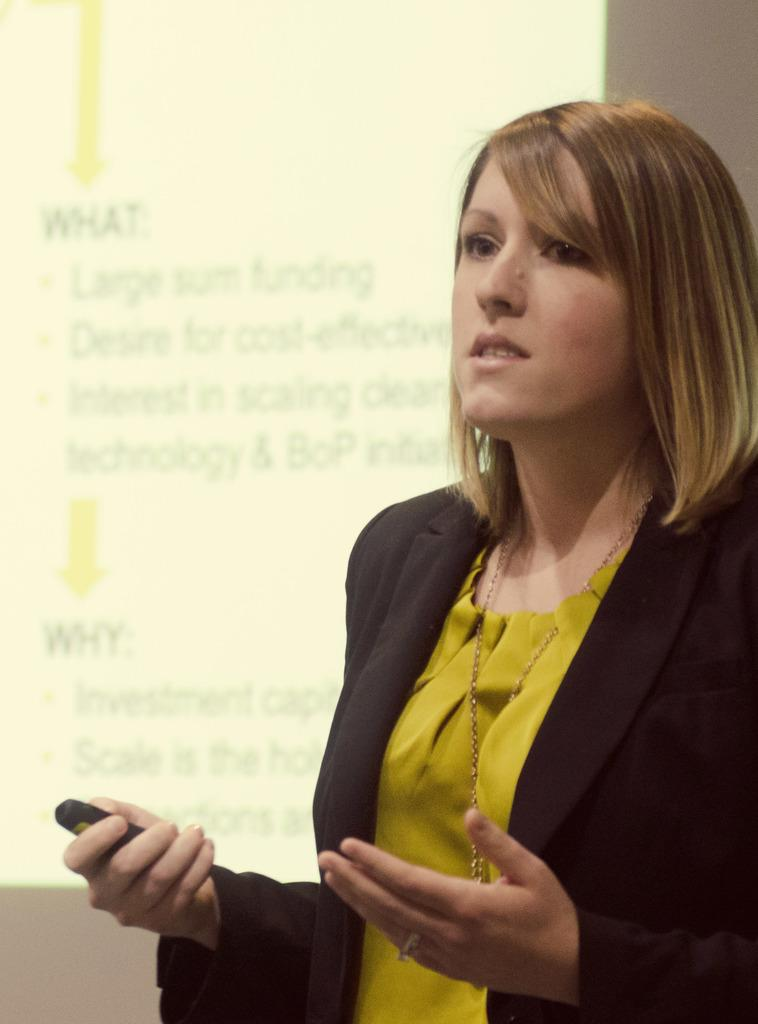Who is the main subject in the image? There is a woman in the image. What is the woman holding in the image? The woman is holding an electronic gadget. What type of clothing is the woman wearing? The woman is wearing a jacket. Can you describe the background of the image? There might be a projector screen in the background of the image, and if present, text is visible on it. What type of haircut does the boy have in the image? There is no boy present in the image, only a woman. What type of law practice does the lawyer in the image specialize in? There is no lawyer present in the image, only a woman holding an electronic gadget. 